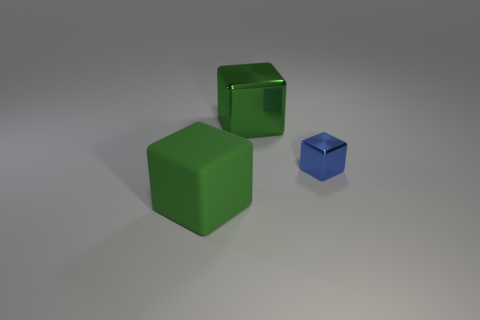Is there any other thing that has the same size as the blue cube?
Keep it short and to the point. No. There is a big green block that is in front of the object that is behind the small blue metallic block; is there a big green object that is right of it?
Your response must be concise. Yes. Are the big thing behind the green matte block and the small block made of the same material?
Your answer should be compact. Yes. What color is the other metallic object that is the same shape as the small blue object?
Provide a succinct answer. Green. Is there any other thing that is the same shape as the blue shiny object?
Make the answer very short. Yes. Are there an equal number of big green cubes in front of the tiny shiny object and matte blocks?
Your response must be concise. Yes. There is a blue shiny cube; are there any green blocks behind it?
Provide a short and direct response. Yes. What size is the metal block that is in front of the green thing behind the small blue metal cube in front of the big metallic object?
Make the answer very short. Small. Does the thing that is in front of the tiny blue metallic thing have the same shape as the metal thing right of the large green shiny block?
Make the answer very short. Yes. The other green object that is the same shape as the large metallic thing is what size?
Your answer should be compact. Large. 